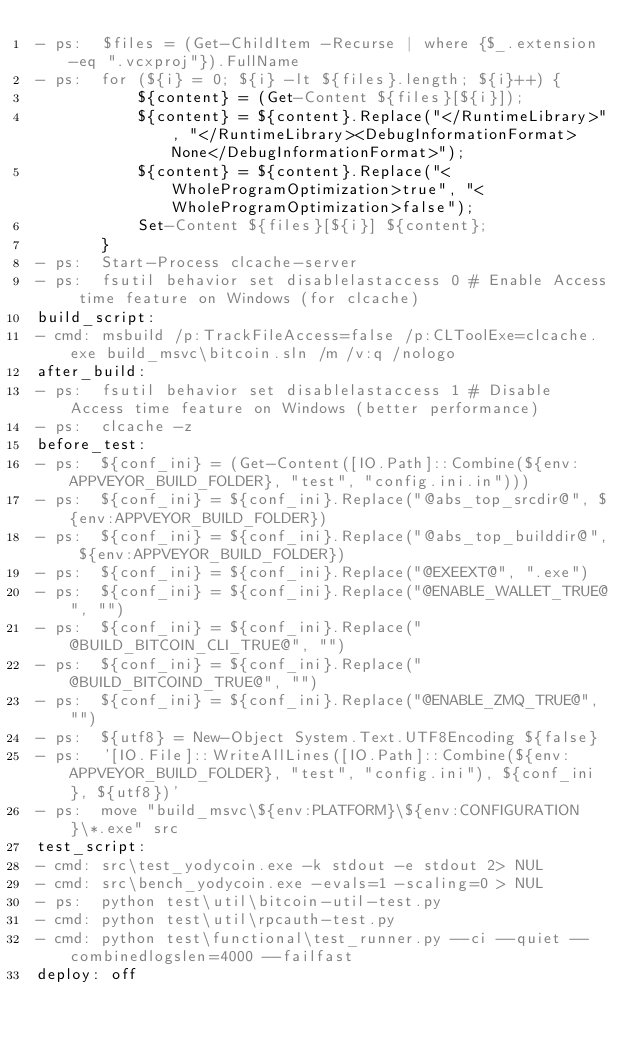<code> <loc_0><loc_0><loc_500><loc_500><_YAML_>- ps:  $files = (Get-ChildItem -Recurse | where {$_.extension -eq ".vcxproj"}).FullName
- ps:  for (${i} = 0; ${i} -lt ${files}.length; ${i}++) {
           ${content} = (Get-Content ${files}[${i}]);
           ${content} = ${content}.Replace("</RuntimeLibrary>", "</RuntimeLibrary><DebugInformationFormat>None</DebugInformationFormat>");
           ${content} = ${content}.Replace("<WholeProgramOptimization>true", "<WholeProgramOptimization>false");
           Set-Content ${files}[${i}] ${content};
       }
- ps:  Start-Process clcache-server
- ps:  fsutil behavior set disablelastaccess 0 # Enable Access time feature on Windows (for clcache)
build_script:
- cmd: msbuild /p:TrackFileAccess=false /p:CLToolExe=clcache.exe build_msvc\bitcoin.sln /m /v:q /nologo
after_build:
- ps:  fsutil behavior set disablelastaccess 1 # Disable Access time feature on Windows (better performance)
- ps:  clcache -z
before_test:
- ps:  ${conf_ini} = (Get-Content([IO.Path]::Combine(${env:APPVEYOR_BUILD_FOLDER}, "test", "config.ini.in")))
- ps:  ${conf_ini} = ${conf_ini}.Replace("@abs_top_srcdir@", ${env:APPVEYOR_BUILD_FOLDER})
- ps:  ${conf_ini} = ${conf_ini}.Replace("@abs_top_builddir@", ${env:APPVEYOR_BUILD_FOLDER})
- ps:  ${conf_ini} = ${conf_ini}.Replace("@EXEEXT@", ".exe")
- ps:  ${conf_ini} = ${conf_ini}.Replace("@ENABLE_WALLET_TRUE@", "")
- ps:  ${conf_ini} = ${conf_ini}.Replace("@BUILD_BITCOIN_CLI_TRUE@", "")
- ps:  ${conf_ini} = ${conf_ini}.Replace("@BUILD_BITCOIND_TRUE@", "")
- ps:  ${conf_ini} = ${conf_ini}.Replace("@ENABLE_ZMQ_TRUE@", "")
- ps:  ${utf8} = New-Object System.Text.UTF8Encoding ${false}
- ps:  '[IO.File]::WriteAllLines([IO.Path]::Combine(${env:APPVEYOR_BUILD_FOLDER}, "test", "config.ini"), ${conf_ini}, ${utf8})'
- ps:  move "build_msvc\${env:PLATFORM}\${env:CONFIGURATION}\*.exe" src
test_script:
- cmd: src\test_yodycoin.exe -k stdout -e stdout 2> NUL
- cmd: src\bench_yodycoin.exe -evals=1 -scaling=0 > NUL
- ps:  python test\util\bitcoin-util-test.py
- cmd: python test\util\rpcauth-test.py
- cmd: python test\functional\test_runner.py --ci --quiet --combinedlogslen=4000 --failfast
deploy: off
</code> 